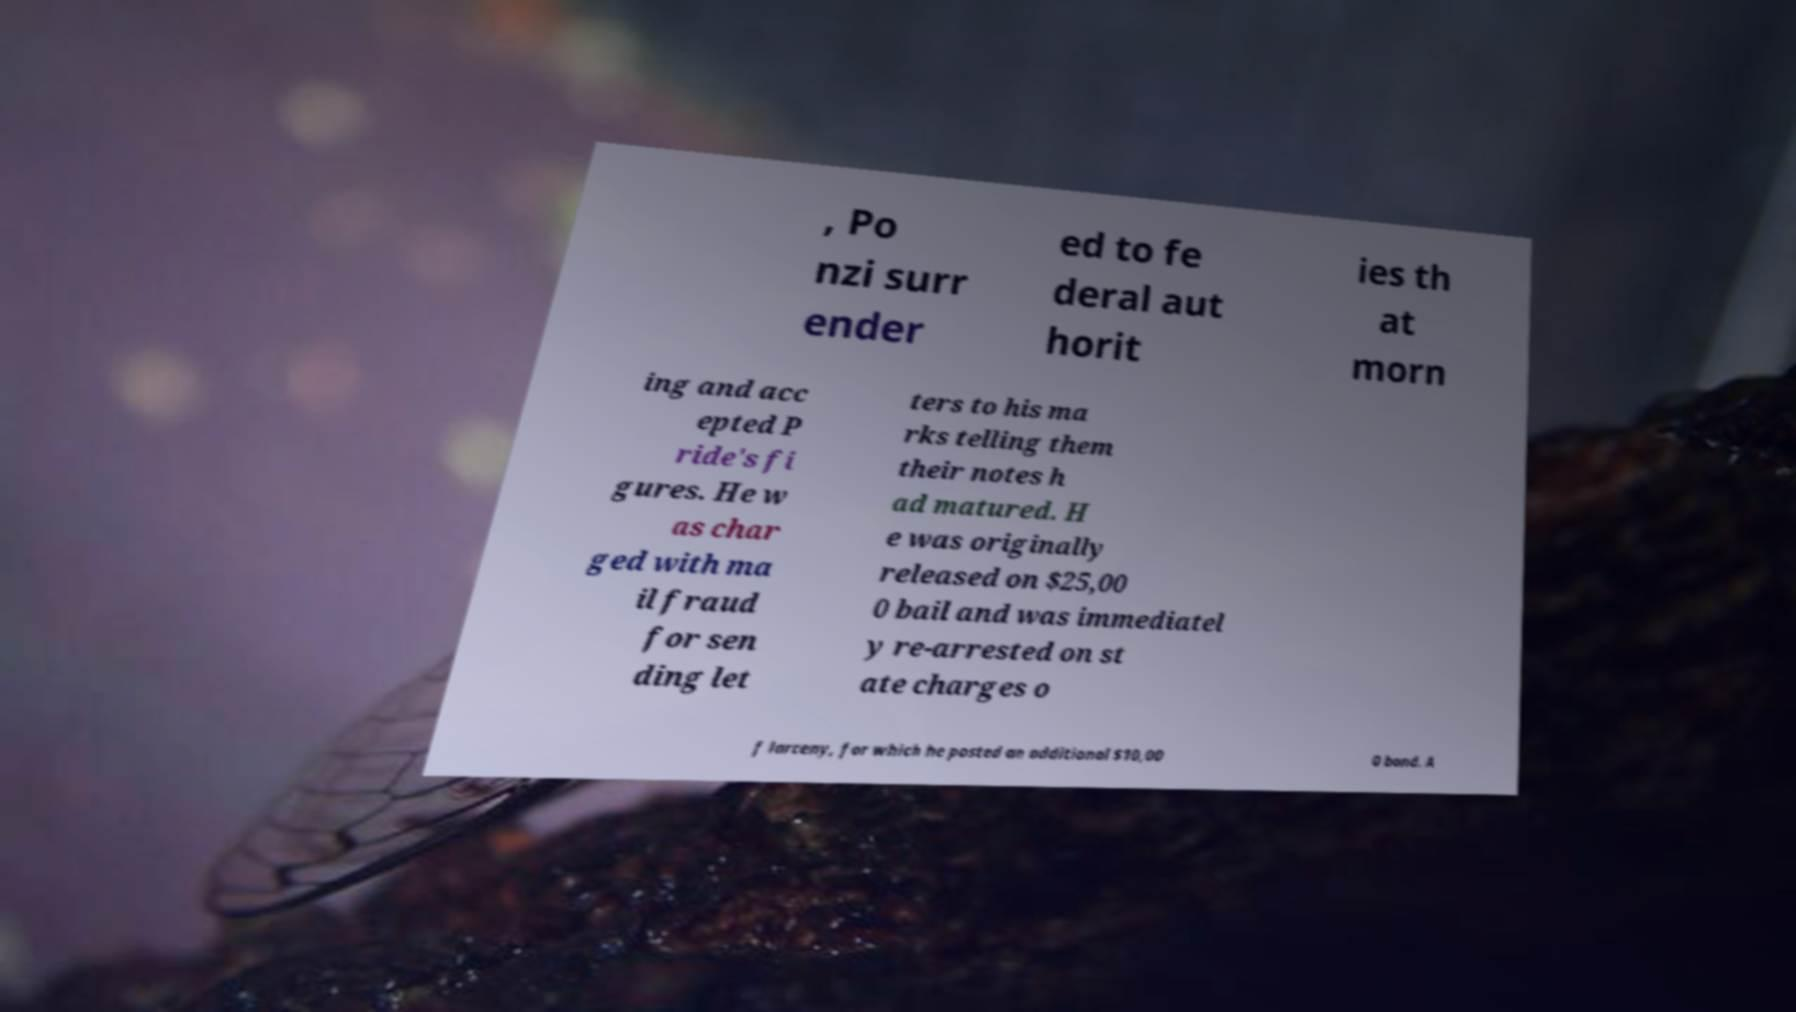I need the written content from this picture converted into text. Can you do that? , Po nzi surr ender ed to fe deral aut horit ies th at morn ing and acc epted P ride's fi gures. He w as char ged with ma il fraud for sen ding let ters to his ma rks telling them their notes h ad matured. H e was originally released on $25,00 0 bail and was immediatel y re-arrested on st ate charges o f larceny, for which he posted an additional $10,00 0 bond. A 